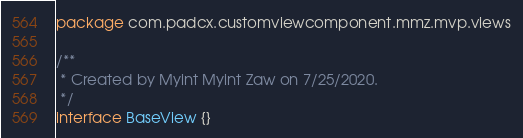<code> <loc_0><loc_0><loc_500><loc_500><_Kotlin_>package com.padcx.customviewcomponent.mmz.mvp.views

/**
 * Created by Myint Myint Zaw on 7/25/2020.
 */
interface BaseView {}</code> 